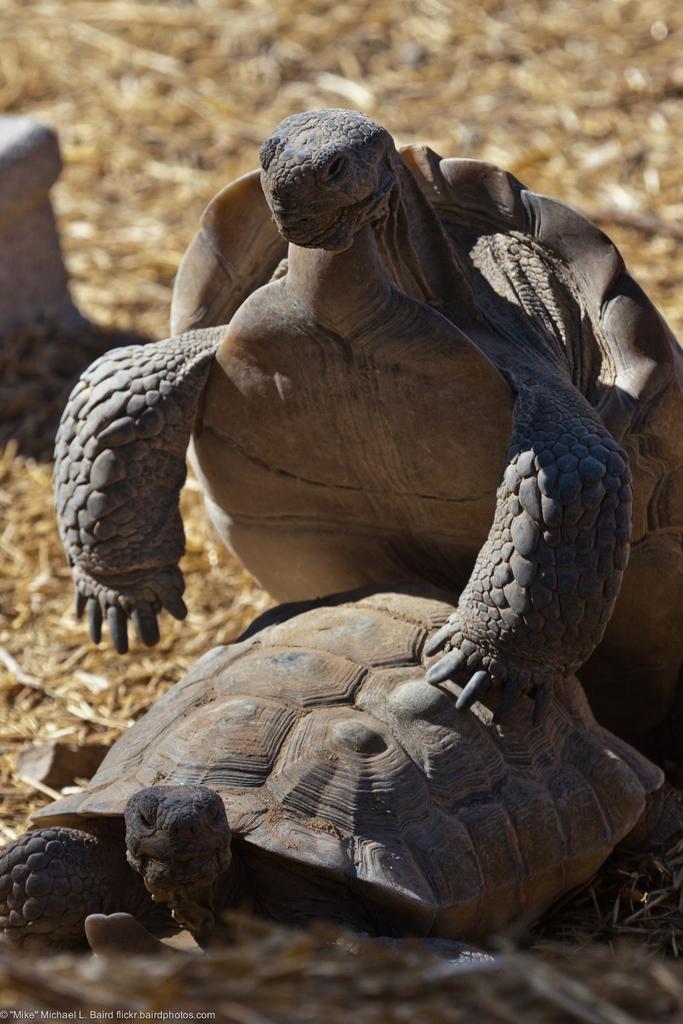Please provide a concise description of this image. In this image there are tortoises on a land. 